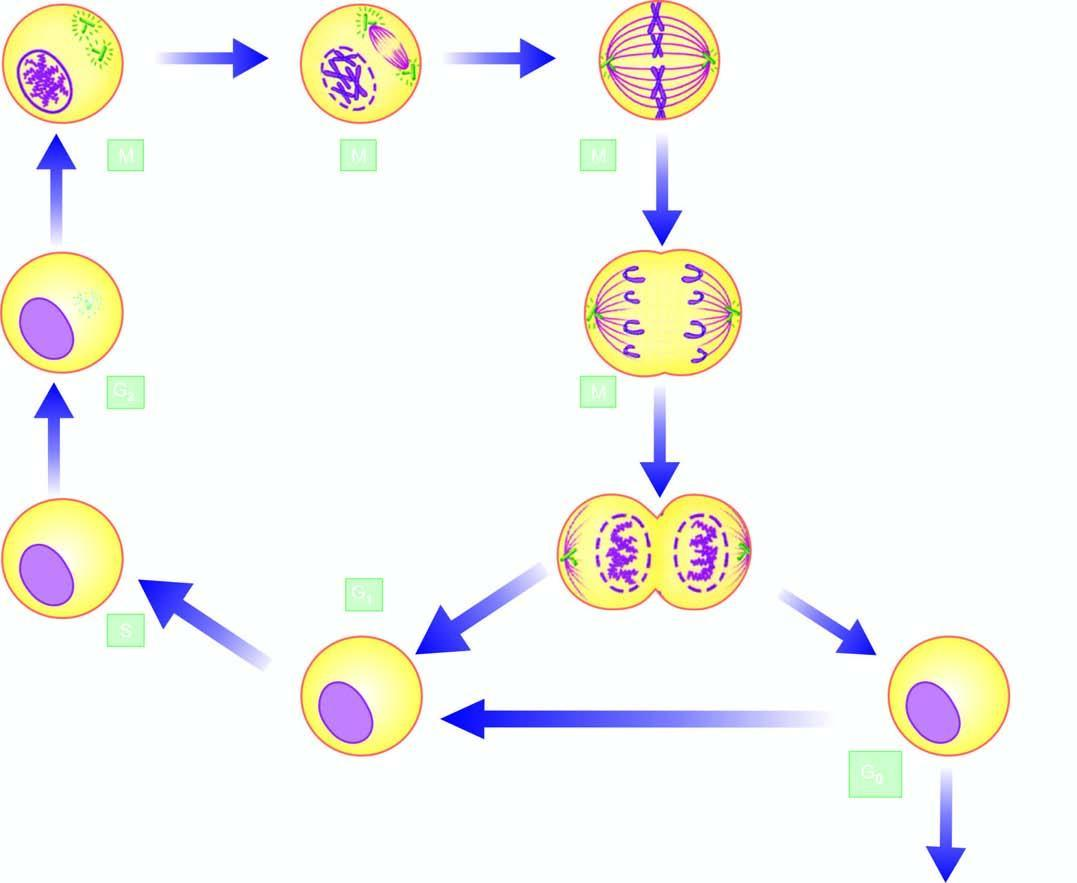how are two daughter cells formed?
Answer the question using a single word or phrase. On completion of division 